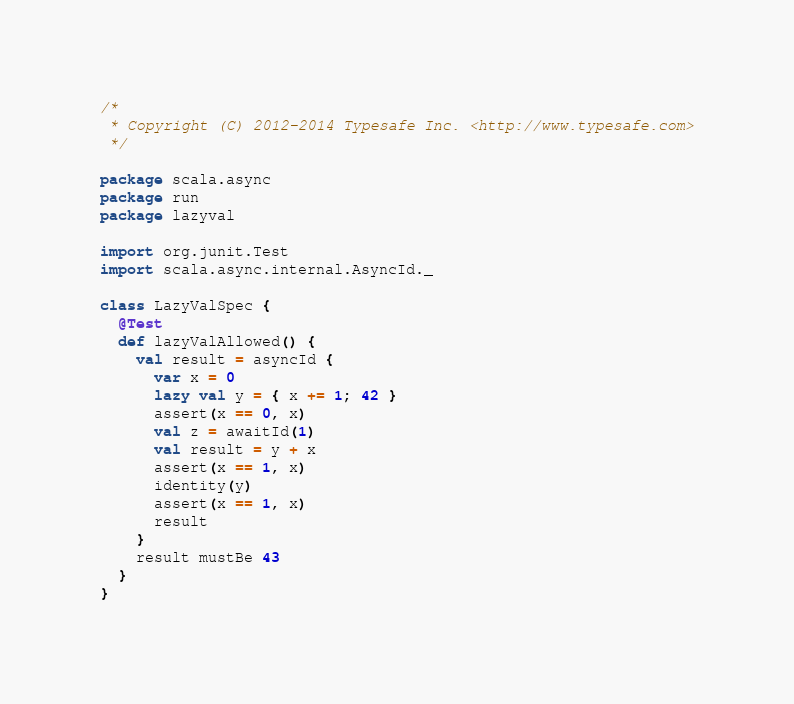<code> <loc_0><loc_0><loc_500><loc_500><_Scala_>/*
 * Copyright (C) 2012-2014 Typesafe Inc. <http://www.typesafe.com>
 */

package scala.async
package run
package lazyval

import org.junit.Test
import scala.async.internal.AsyncId._

class LazyValSpec {
  @Test
  def lazyValAllowed() {
    val result = asyncId {
      var x = 0
      lazy val y = { x += 1; 42 }
      assert(x == 0, x)
      val z = awaitId(1)
      val result = y + x
      assert(x == 1, x)
      identity(y)
      assert(x == 1, x)
      result
    }
    result mustBe 43
  }
}

</code> 